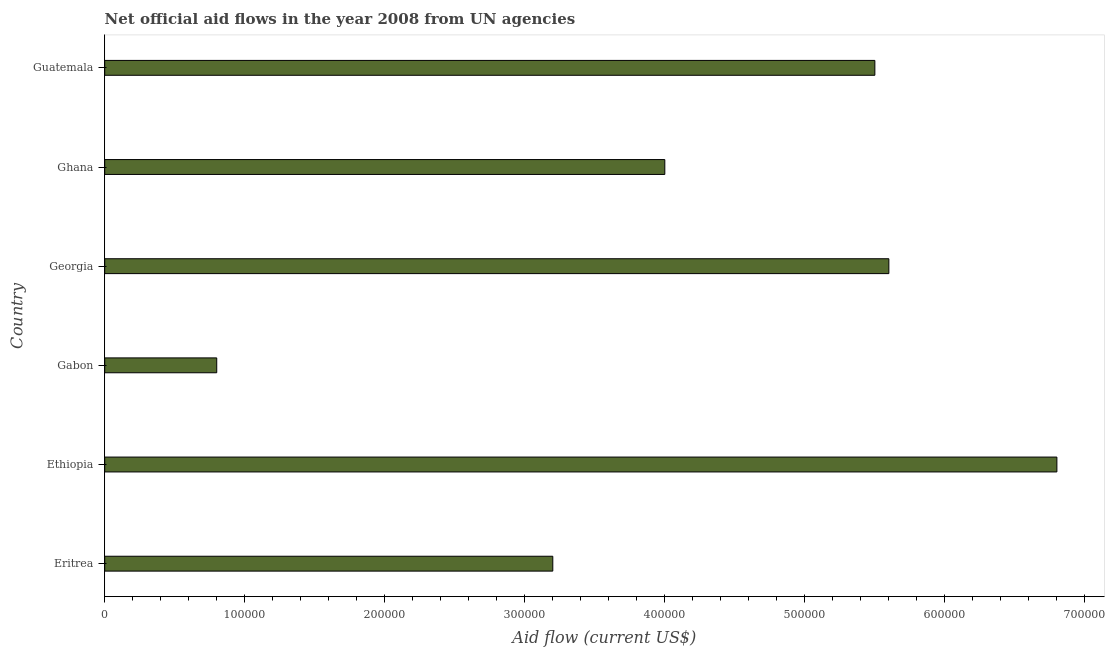Does the graph contain any zero values?
Provide a short and direct response. No. What is the title of the graph?
Offer a terse response. Net official aid flows in the year 2008 from UN agencies. What is the label or title of the Y-axis?
Give a very brief answer. Country. What is the net official flows from un agencies in Guatemala?
Ensure brevity in your answer.  5.50e+05. Across all countries, what is the maximum net official flows from un agencies?
Ensure brevity in your answer.  6.80e+05. In which country was the net official flows from un agencies maximum?
Give a very brief answer. Ethiopia. In which country was the net official flows from un agencies minimum?
Your answer should be very brief. Gabon. What is the sum of the net official flows from un agencies?
Provide a short and direct response. 2.59e+06. What is the average net official flows from un agencies per country?
Your answer should be compact. 4.32e+05. What is the median net official flows from un agencies?
Keep it short and to the point. 4.75e+05. In how many countries, is the net official flows from un agencies greater than 460000 US$?
Provide a short and direct response. 3. What is the ratio of the net official flows from un agencies in Gabon to that in Georgia?
Give a very brief answer. 0.14. Is the difference between the net official flows from un agencies in Gabon and Guatemala greater than the difference between any two countries?
Keep it short and to the point. No. What is the difference between the highest and the second highest net official flows from un agencies?
Keep it short and to the point. 1.20e+05. Is the sum of the net official flows from un agencies in Eritrea and Gabon greater than the maximum net official flows from un agencies across all countries?
Give a very brief answer. No. What is the difference between the highest and the lowest net official flows from un agencies?
Keep it short and to the point. 6.00e+05. Are all the bars in the graph horizontal?
Offer a terse response. Yes. How many countries are there in the graph?
Your answer should be compact. 6. What is the Aid flow (current US$) in Ethiopia?
Offer a terse response. 6.80e+05. What is the Aid flow (current US$) in Gabon?
Keep it short and to the point. 8.00e+04. What is the Aid flow (current US$) in Georgia?
Offer a terse response. 5.60e+05. What is the difference between the Aid flow (current US$) in Eritrea and Ethiopia?
Keep it short and to the point. -3.60e+05. What is the difference between the Aid flow (current US$) in Eritrea and Gabon?
Your answer should be very brief. 2.40e+05. What is the difference between the Aid flow (current US$) in Eritrea and Guatemala?
Offer a very short reply. -2.30e+05. What is the difference between the Aid flow (current US$) in Ethiopia and Gabon?
Keep it short and to the point. 6.00e+05. What is the difference between the Aid flow (current US$) in Ethiopia and Ghana?
Ensure brevity in your answer.  2.80e+05. What is the difference between the Aid flow (current US$) in Gabon and Georgia?
Ensure brevity in your answer.  -4.80e+05. What is the difference between the Aid flow (current US$) in Gabon and Ghana?
Offer a terse response. -3.20e+05. What is the difference between the Aid flow (current US$) in Gabon and Guatemala?
Keep it short and to the point. -4.70e+05. What is the difference between the Aid flow (current US$) in Georgia and Ghana?
Your answer should be compact. 1.60e+05. What is the ratio of the Aid flow (current US$) in Eritrea to that in Ethiopia?
Keep it short and to the point. 0.47. What is the ratio of the Aid flow (current US$) in Eritrea to that in Georgia?
Keep it short and to the point. 0.57. What is the ratio of the Aid flow (current US$) in Eritrea to that in Ghana?
Offer a terse response. 0.8. What is the ratio of the Aid flow (current US$) in Eritrea to that in Guatemala?
Offer a very short reply. 0.58. What is the ratio of the Aid flow (current US$) in Ethiopia to that in Gabon?
Provide a succinct answer. 8.5. What is the ratio of the Aid flow (current US$) in Ethiopia to that in Georgia?
Make the answer very short. 1.21. What is the ratio of the Aid flow (current US$) in Ethiopia to that in Guatemala?
Your answer should be very brief. 1.24. What is the ratio of the Aid flow (current US$) in Gabon to that in Georgia?
Offer a very short reply. 0.14. What is the ratio of the Aid flow (current US$) in Gabon to that in Guatemala?
Give a very brief answer. 0.14. What is the ratio of the Aid flow (current US$) in Georgia to that in Ghana?
Keep it short and to the point. 1.4. What is the ratio of the Aid flow (current US$) in Ghana to that in Guatemala?
Your answer should be compact. 0.73. 